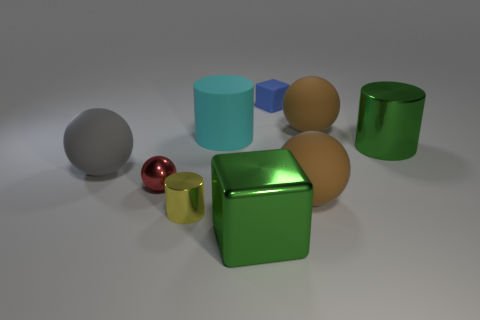There is a metallic cylinder that is the same color as the large shiny cube; what is its size?
Keep it short and to the point. Large. Do the sphere to the left of the red shiny thing and the red shiny ball that is on the left side of the tiny rubber thing have the same size?
Keep it short and to the point. No. What is the size of the metallic object left of the yellow metal object?
Offer a very short reply. Small. Is there a shiny thing of the same color as the large shiny cylinder?
Ensure brevity in your answer.  Yes. Is there a rubber sphere that is behind the metal cylinder in front of the gray ball?
Your response must be concise. Yes. There is a red thing; does it have the same size as the green object that is behind the red thing?
Ensure brevity in your answer.  No. There is a big brown matte object that is in front of the metallic object to the right of the small blue block; is there a large green object that is to the left of it?
Offer a very short reply. Yes. What material is the cylinder left of the big cyan rubber cylinder?
Provide a succinct answer. Metal. Do the green metal cylinder and the cyan rubber thing have the same size?
Give a very brief answer. Yes. The object that is in front of the large cyan matte object and behind the large gray ball is what color?
Provide a short and direct response. Green. 